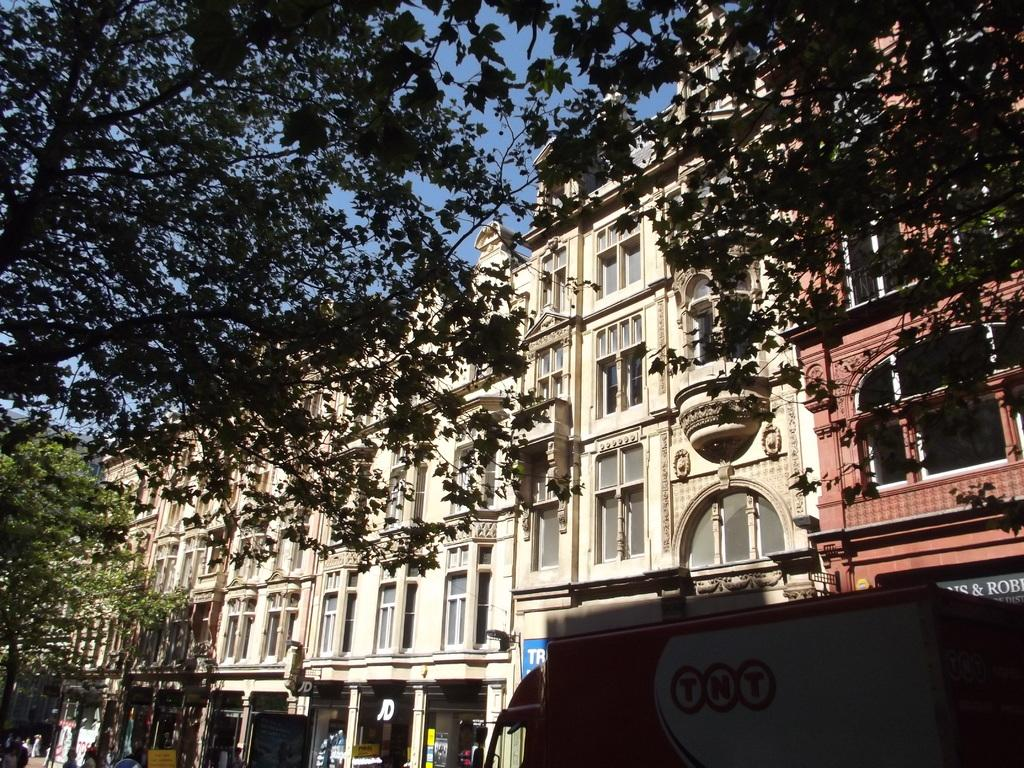What type of vegetation is visible in the image? There are trees in front of the image. What type of structures can be seen in the image? There are buildings in front of the image. What vehicle is present on the right side of the image? There is a truck on the right side of the image. What is visible in the background of the image? The sky is visible in the background of the image. What part of the brain can be seen in the image? There is no brain present in the image; it features trees, buildings, a truck, and the sky. What reason might the truck be in the image? The image does not provide any information about the reason for the truck's presence; it simply shows the truck on the right side of the image. 